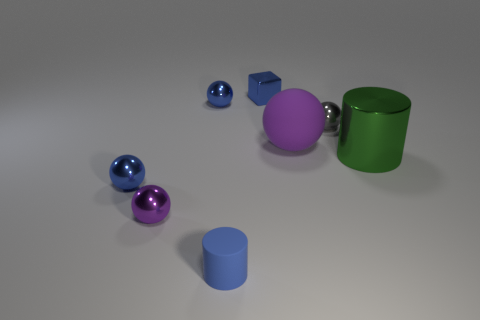Are the gray object and the tiny thing in front of the small purple sphere made of the same material?
Ensure brevity in your answer.  No. Are there any other things that have the same material as the tiny purple sphere?
Provide a short and direct response. Yes. Are there more matte balls than big metal cubes?
Your answer should be compact. Yes. There is a object on the right side of the gray sphere behind the small blue sphere in front of the tiny gray ball; what is its shape?
Your response must be concise. Cylinder. Is the tiny ball that is on the right side of the blue cylinder made of the same material as the green thing that is on the right side of the small shiny cube?
Your response must be concise. Yes. The green thing that is the same material as the tiny purple object is what shape?
Offer a very short reply. Cylinder. Are there any other things of the same color as the large sphere?
Offer a very short reply. Yes. What number of big matte spheres are there?
Keep it short and to the point. 1. What material is the purple object left of the purple ball to the right of the tiny blue cube?
Ensure brevity in your answer.  Metal. The small metal sphere that is to the right of the purple thing that is to the right of the rubber thing that is in front of the metal cylinder is what color?
Make the answer very short. Gray. 